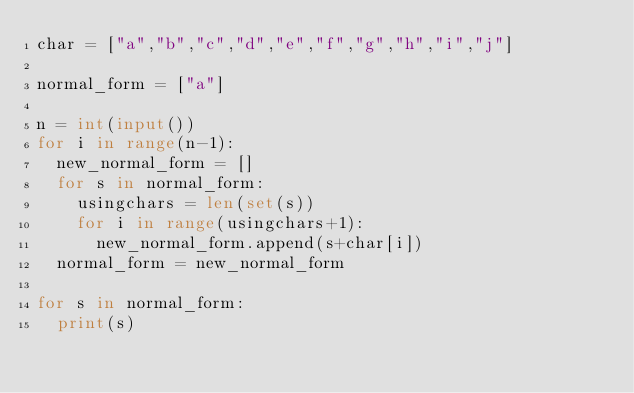Convert code to text. <code><loc_0><loc_0><loc_500><loc_500><_Python_>char = ["a","b","c","d","e","f","g","h","i","j"]

normal_form = ["a"]

n = int(input())
for i in range(n-1):
  new_normal_form = []
  for s in normal_form:
    usingchars = len(set(s))
    for i in range(usingchars+1):
      new_normal_form.append(s+char[i])
  normal_form = new_normal_form

for s in normal_form:
  print(s)</code> 